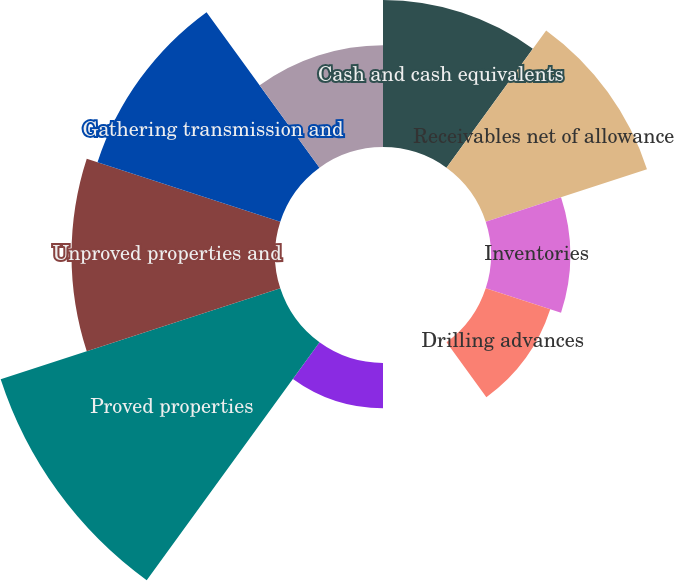<chart> <loc_0><loc_0><loc_500><loc_500><pie_chart><fcel>Cash and cash equivalents<fcel>Receivables net of allowance<fcel>Inventories<fcel>Drilling advances<fcel>Derivative instruments<fcel>Prepaid assets and other<fcel>Proved properties<fcel>Unproved properties and<fcel>Gathering transmission and<fcel>Other<nl><fcel>11.3%<fcel>13.04%<fcel>6.09%<fcel>5.22%<fcel>0.0%<fcel>3.48%<fcel>22.61%<fcel>15.65%<fcel>14.78%<fcel>7.83%<nl></chart> 